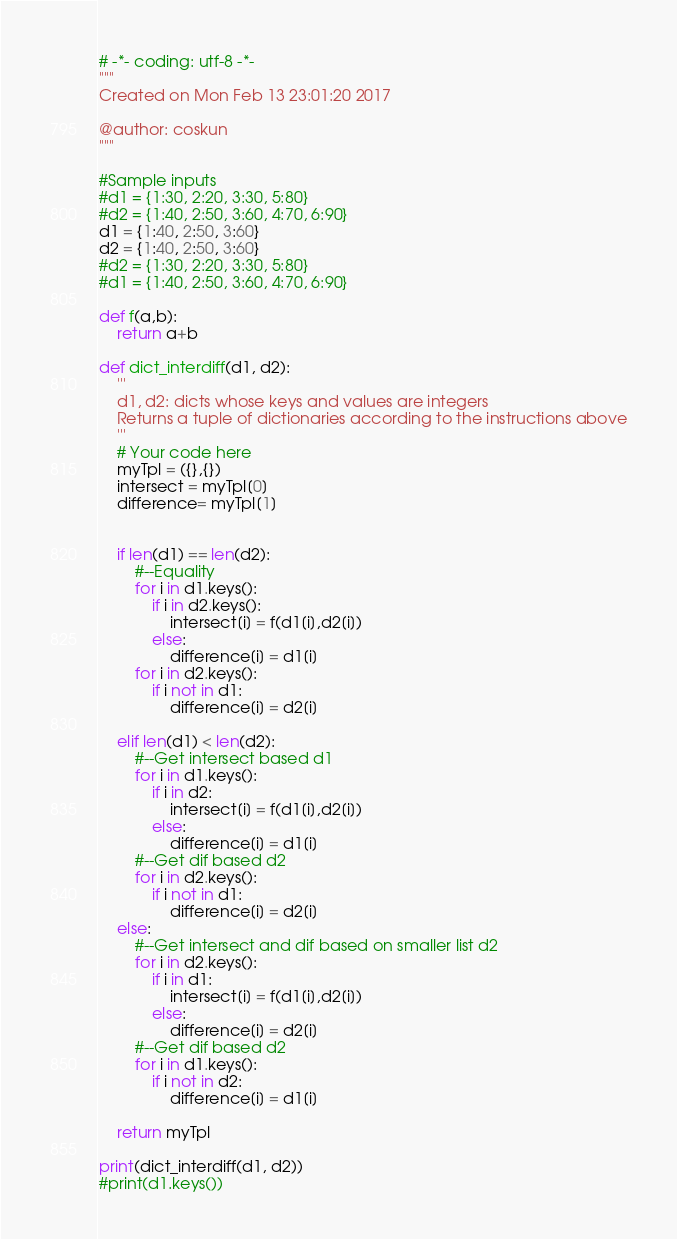<code> <loc_0><loc_0><loc_500><loc_500><_Python_># -*- coding: utf-8 -*-
"""
Created on Mon Feb 13 23:01:20 2017

@author: coskun
"""

#Sample inputs
#d1 = {1:30, 2:20, 3:30, 5:80}
#d2 = {1:40, 2:50, 3:60, 4:70, 6:90}
d1 = {1:40, 2:50, 3:60}
d2 = {1:40, 2:50, 3:60}
#d2 = {1:30, 2:20, 3:30, 5:80}
#d1 = {1:40, 2:50, 3:60, 4:70, 6:90}

def f(a,b):
    return a+b

def dict_interdiff(d1, d2):
    '''
    d1, d2: dicts whose keys and values are integers
    Returns a tuple of dictionaries according to the instructions above
    '''
    # Your code here
    myTpl = ({},{})
    intersect = myTpl[0]
    difference= myTpl[1]
    
    
    if len(d1) == len(d2):
        #--Equality
        for i in d1.keys():
            if i in d2.keys():
                intersect[i] = f(d1[i],d2[i])
            else:
                difference[i] = d1[i]
        for i in d2.keys():
            if i not in d1:
                difference[i] = d2[i]
    
    elif len(d1) < len(d2):
        #--Get intersect based d1
        for i in d1.keys():
            if i in d2:
                intersect[i] = f(d1[i],d2[i])
            else:
                difference[i] = d1[i]
        #--Get dif based d2
        for i in d2.keys():
            if i not in d1:
                difference[i] = d2[i]
    else:
        #--Get intersect and dif based on smaller list d2
        for i in d2.keys():
            if i in d1:
                intersect[i] = f(d1[i],d2[i])
            else:
                difference[i] = d2[i]
        #--Get dif based d2
        for i in d1.keys():
            if i not in d2:
                difference[i] = d1[i]
    
    return myTpl
    
print(dict_interdiff(d1, d2))
#print(d1.keys())</code> 